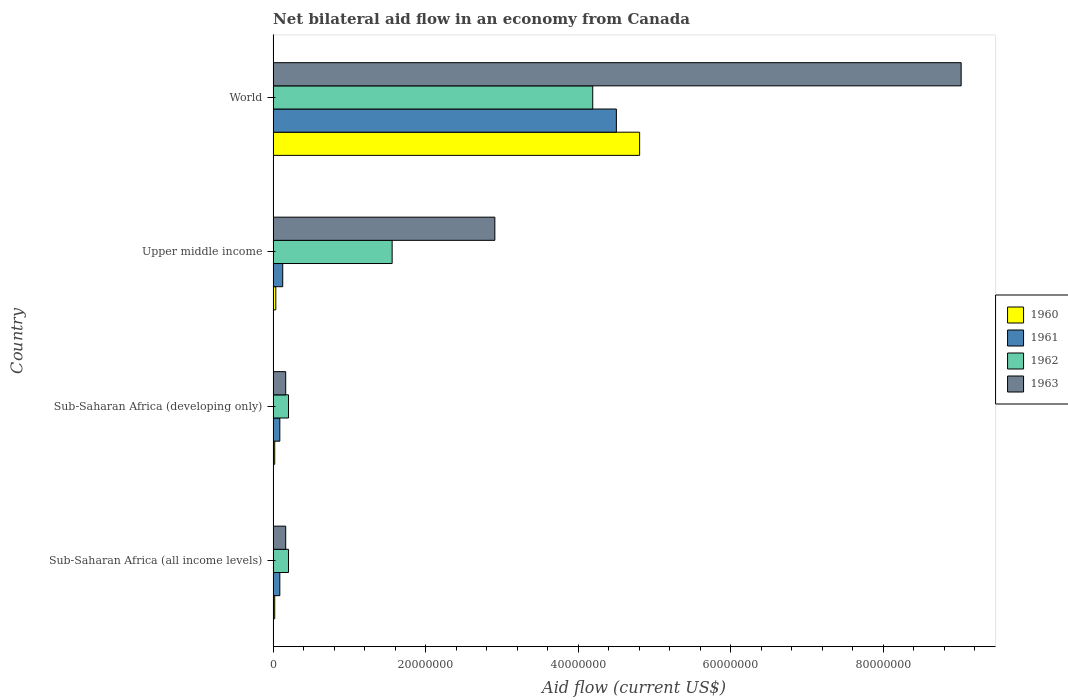How many different coloured bars are there?
Your response must be concise. 4. Are the number of bars per tick equal to the number of legend labels?
Keep it short and to the point. Yes. Are the number of bars on each tick of the Y-axis equal?
Give a very brief answer. Yes. What is the label of the 2nd group of bars from the top?
Your response must be concise. Upper middle income. What is the net bilateral aid flow in 1960 in Sub-Saharan Africa (all income levels)?
Ensure brevity in your answer.  2.10e+05. Across all countries, what is the maximum net bilateral aid flow in 1962?
Give a very brief answer. 4.19e+07. In which country was the net bilateral aid flow in 1963 minimum?
Keep it short and to the point. Sub-Saharan Africa (all income levels). What is the total net bilateral aid flow in 1961 in the graph?
Offer a terse response. 4.80e+07. What is the difference between the net bilateral aid flow in 1960 in World and the net bilateral aid flow in 1963 in Upper middle income?
Provide a succinct answer. 1.90e+07. What is the average net bilateral aid flow in 1961 per country?
Your answer should be compact. 1.20e+07. What is the difference between the net bilateral aid flow in 1962 and net bilateral aid flow in 1961 in World?
Offer a very short reply. -3.10e+06. In how many countries, is the net bilateral aid flow in 1960 greater than 76000000 US$?
Offer a very short reply. 0. What is the difference between the highest and the second highest net bilateral aid flow in 1960?
Give a very brief answer. 4.77e+07. What is the difference between the highest and the lowest net bilateral aid flow in 1961?
Offer a very short reply. 4.41e+07. Is the sum of the net bilateral aid flow in 1960 in Sub-Saharan Africa (developing only) and Upper middle income greater than the maximum net bilateral aid flow in 1961 across all countries?
Offer a terse response. No. Is it the case that in every country, the sum of the net bilateral aid flow in 1961 and net bilateral aid flow in 1963 is greater than the sum of net bilateral aid flow in 1962 and net bilateral aid flow in 1960?
Provide a short and direct response. No. Does the graph contain any zero values?
Offer a terse response. No. Does the graph contain grids?
Your response must be concise. No. What is the title of the graph?
Your answer should be very brief. Net bilateral aid flow in an economy from Canada. Does "2005" appear as one of the legend labels in the graph?
Provide a short and direct response. No. What is the label or title of the X-axis?
Keep it short and to the point. Aid flow (current US$). What is the label or title of the Y-axis?
Provide a succinct answer. Country. What is the Aid flow (current US$) of 1960 in Sub-Saharan Africa (all income levels)?
Provide a succinct answer. 2.10e+05. What is the Aid flow (current US$) in 1961 in Sub-Saharan Africa (all income levels)?
Keep it short and to the point. 8.80e+05. What is the Aid flow (current US$) of 1962 in Sub-Saharan Africa (all income levels)?
Your response must be concise. 2.02e+06. What is the Aid flow (current US$) in 1963 in Sub-Saharan Africa (all income levels)?
Ensure brevity in your answer.  1.65e+06. What is the Aid flow (current US$) of 1960 in Sub-Saharan Africa (developing only)?
Give a very brief answer. 2.10e+05. What is the Aid flow (current US$) of 1961 in Sub-Saharan Africa (developing only)?
Your answer should be very brief. 8.80e+05. What is the Aid flow (current US$) in 1962 in Sub-Saharan Africa (developing only)?
Offer a terse response. 2.02e+06. What is the Aid flow (current US$) of 1963 in Sub-Saharan Africa (developing only)?
Ensure brevity in your answer.  1.65e+06. What is the Aid flow (current US$) of 1960 in Upper middle income?
Your answer should be very brief. 3.50e+05. What is the Aid flow (current US$) in 1961 in Upper middle income?
Give a very brief answer. 1.26e+06. What is the Aid flow (current US$) in 1962 in Upper middle income?
Your answer should be very brief. 1.56e+07. What is the Aid flow (current US$) in 1963 in Upper middle income?
Ensure brevity in your answer.  2.91e+07. What is the Aid flow (current US$) in 1960 in World?
Offer a very short reply. 4.81e+07. What is the Aid flow (current US$) in 1961 in World?
Your answer should be very brief. 4.50e+07. What is the Aid flow (current US$) of 1962 in World?
Your answer should be compact. 4.19e+07. What is the Aid flow (current US$) in 1963 in World?
Offer a very short reply. 9.02e+07. Across all countries, what is the maximum Aid flow (current US$) of 1960?
Your answer should be compact. 4.81e+07. Across all countries, what is the maximum Aid flow (current US$) of 1961?
Offer a very short reply. 4.50e+07. Across all countries, what is the maximum Aid flow (current US$) of 1962?
Offer a terse response. 4.19e+07. Across all countries, what is the maximum Aid flow (current US$) in 1963?
Keep it short and to the point. 9.02e+07. Across all countries, what is the minimum Aid flow (current US$) in 1960?
Keep it short and to the point. 2.10e+05. Across all countries, what is the minimum Aid flow (current US$) of 1961?
Your answer should be very brief. 8.80e+05. Across all countries, what is the minimum Aid flow (current US$) in 1962?
Offer a terse response. 2.02e+06. Across all countries, what is the minimum Aid flow (current US$) of 1963?
Make the answer very short. 1.65e+06. What is the total Aid flow (current US$) in 1960 in the graph?
Offer a very short reply. 4.88e+07. What is the total Aid flow (current US$) of 1961 in the graph?
Provide a succinct answer. 4.80e+07. What is the total Aid flow (current US$) of 1962 in the graph?
Offer a very short reply. 6.16e+07. What is the total Aid flow (current US$) of 1963 in the graph?
Keep it short and to the point. 1.23e+08. What is the difference between the Aid flow (current US$) in 1960 in Sub-Saharan Africa (all income levels) and that in Sub-Saharan Africa (developing only)?
Provide a short and direct response. 0. What is the difference between the Aid flow (current US$) of 1962 in Sub-Saharan Africa (all income levels) and that in Sub-Saharan Africa (developing only)?
Your answer should be compact. 0. What is the difference between the Aid flow (current US$) of 1961 in Sub-Saharan Africa (all income levels) and that in Upper middle income?
Provide a short and direct response. -3.80e+05. What is the difference between the Aid flow (current US$) of 1962 in Sub-Saharan Africa (all income levels) and that in Upper middle income?
Make the answer very short. -1.36e+07. What is the difference between the Aid flow (current US$) of 1963 in Sub-Saharan Africa (all income levels) and that in Upper middle income?
Give a very brief answer. -2.74e+07. What is the difference between the Aid flow (current US$) of 1960 in Sub-Saharan Africa (all income levels) and that in World?
Make the answer very short. -4.79e+07. What is the difference between the Aid flow (current US$) of 1961 in Sub-Saharan Africa (all income levels) and that in World?
Provide a succinct answer. -4.41e+07. What is the difference between the Aid flow (current US$) in 1962 in Sub-Saharan Africa (all income levels) and that in World?
Offer a terse response. -3.99e+07. What is the difference between the Aid flow (current US$) in 1963 in Sub-Saharan Africa (all income levels) and that in World?
Offer a very short reply. -8.86e+07. What is the difference between the Aid flow (current US$) in 1961 in Sub-Saharan Africa (developing only) and that in Upper middle income?
Offer a terse response. -3.80e+05. What is the difference between the Aid flow (current US$) of 1962 in Sub-Saharan Africa (developing only) and that in Upper middle income?
Give a very brief answer. -1.36e+07. What is the difference between the Aid flow (current US$) of 1963 in Sub-Saharan Africa (developing only) and that in Upper middle income?
Your response must be concise. -2.74e+07. What is the difference between the Aid flow (current US$) of 1960 in Sub-Saharan Africa (developing only) and that in World?
Offer a very short reply. -4.79e+07. What is the difference between the Aid flow (current US$) of 1961 in Sub-Saharan Africa (developing only) and that in World?
Give a very brief answer. -4.41e+07. What is the difference between the Aid flow (current US$) in 1962 in Sub-Saharan Africa (developing only) and that in World?
Your answer should be compact. -3.99e+07. What is the difference between the Aid flow (current US$) in 1963 in Sub-Saharan Africa (developing only) and that in World?
Your answer should be very brief. -8.86e+07. What is the difference between the Aid flow (current US$) of 1960 in Upper middle income and that in World?
Give a very brief answer. -4.77e+07. What is the difference between the Aid flow (current US$) in 1961 in Upper middle income and that in World?
Your response must be concise. -4.38e+07. What is the difference between the Aid flow (current US$) of 1962 in Upper middle income and that in World?
Your answer should be compact. -2.63e+07. What is the difference between the Aid flow (current US$) of 1963 in Upper middle income and that in World?
Make the answer very short. -6.12e+07. What is the difference between the Aid flow (current US$) in 1960 in Sub-Saharan Africa (all income levels) and the Aid flow (current US$) in 1961 in Sub-Saharan Africa (developing only)?
Offer a very short reply. -6.70e+05. What is the difference between the Aid flow (current US$) of 1960 in Sub-Saharan Africa (all income levels) and the Aid flow (current US$) of 1962 in Sub-Saharan Africa (developing only)?
Give a very brief answer. -1.81e+06. What is the difference between the Aid flow (current US$) of 1960 in Sub-Saharan Africa (all income levels) and the Aid flow (current US$) of 1963 in Sub-Saharan Africa (developing only)?
Give a very brief answer. -1.44e+06. What is the difference between the Aid flow (current US$) in 1961 in Sub-Saharan Africa (all income levels) and the Aid flow (current US$) in 1962 in Sub-Saharan Africa (developing only)?
Provide a succinct answer. -1.14e+06. What is the difference between the Aid flow (current US$) in 1961 in Sub-Saharan Africa (all income levels) and the Aid flow (current US$) in 1963 in Sub-Saharan Africa (developing only)?
Your response must be concise. -7.70e+05. What is the difference between the Aid flow (current US$) of 1962 in Sub-Saharan Africa (all income levels) and the Aid flow (current US$) of 1963 in Sub-Saharan Africa (developing only)?
Your response must be concise. 3.70e+05. What is the difference between the Aid flow (current US$) in 1960 in Sub-Saharan Africa (all income levels) and the Aid flow (current US$) in 1961 in Upper middle income?
Give a very brief answer. -1.05e+06. What is the difference between the Aid flow (current US$) of 1960 in Sub-Saharan Africa (all income levels) and the Aid flow (current US$) of 1962 in Upper middle income?
Your answer should be very brief. -1.54e+07. What is the difference between the Aid flow (current US$) of 1960 in Sub-Saharan Africa (all income levels) and the Aid flow (current US$) of 1963 in Upper middle income?
Your answer should be very brief. -2.89e+07. What is the difference between the Aid flow (current US$) in 1961 in Sub-Saharan Africa (all income levels) and the Aid flow (current US$) in 1962 in Upper middle income?
Provide a succinct answer. -1.47e+07. What is the difference between the Aid flow (current US$) of 1961 in Sub-Saharan Africa (all income levels) and the Aid flow (current US$) of 1963 in Upper middle income?
Offer a very short reply. -2.82e+07. What is the difference between the Aid flow (current US$) of 1962 in Sub-Saharan Africa (all income levels) and the Aid flow (current US$) of 1963 in Upper middle income?
Keep it short and to the point. -2.71e+07. What is the difference between the Aid flow (current US$) of 1960 in Sub-Saharan Africa (all income levels) and the Aid flow (current US$) of 1961 in World?
Offer a terse response. -4.48e+07. What is the difference between the Aid flow (current US$) in 1960 in Sub-Saharan Africa (all income levels) and the Aid flow (current US$) in 1962 in World?
Provide a short and direct response. -4.17e+07. What is the difference between the Aid flow (current US$) in 1960 in Sub-Saharan Africa (all income levels) and the Aid flow (current US$) in 1963 in World?
Provide a succinct answer. -9.00e+07. What is the difference between the Aid flow (current US$) of 1961 in Sub-Saharan Africa (all income levels) and the Aid flow (current US$) of 1962 in World?
Your answer should be very brief. -4.10e+07. What is the difference between the Aid flow (current US$) in 1961 in Sub-Saharan Africa (all income levels) and the Aid flow (current US$) in 1963 in World?
Your answer should be very brief. -8.94e+07. What is the difference between the Aid flow (current US$) of 1962 in Sub-Saharan Africa (all income levels) and the Aid flow (current US$) of 1963 in World?
Give a very brief answer. -8.82e+07. What is the difference between the Aid flow (current US$) in 1960 in Sub-Saharan Africa (developing only) and the Aid flow (current US$) in 1961 in Upper middle income?
Your response must be concise. -1.05e+06. What is the difference between the Aid flow (current US$) in 1960 in Sub-Saharan Africa (developing only) and the Aid flow (current US$) in 1962 in Upper middle income?
Your answer should be very brief. -1.54e+07. What is the difference between the Aid flow (current US$) of 1960 in Sub-Saharan Africa (developing only) and the Aid flow (current US$) of 1963 in Upper middle income?
Provide a succinct answer. -2.89e+07. What is the difference between the Aid flow (current US$) in 1961 in Sub-Saharan Africa (developing only) and the Aid flow (current US$) in 1962 in Upper middle income?
Offer a very short reply. -1.47e+07. What is the difference between the Aid flow (current US$) of 1961 in Sub-Saharan Africa (developing only) and the Aid flow (current US$) of 1963 in Upper middle income?
Keep it short and to the point. -2.82e+07. What is the difference between the Aid flow (current US$) of 1962 in Sub-Saharan Africa (developing only) and the Aid flow (current US$) of 1963 in Upper middle income?
Your answer should be compact. -2.71e+07. What is the difference between the Aid flow (current US$) of 1960 in Sub-Saharan Africa (developing only) and the Aid flow (current US$) of 1961 in World?
Give a very brief answer. -4.48e+07. What is the difference between the Aid flow (current US$) of 1960 in Sub-Saharan Africa (developing only) and the Aid flow (current US$) of 1962 in World?
Your answer should be compact. -4.17e+07. What is the difference between the Aid flow (current US$) in 1960 in Sub-Saharan Africa (developing only) and the Aid flow (current US$) in 1963 in World?
Make the answer very short. -9.00e+07. What is the difference between the Aid flow (current US$) in 1961 in Sub-Saharan Africa (developing only) and the Aid flow (current US$) in 1962 in World?
Make the answer very short. -4.10e+07. What is the difference between the Aid flow (current US$) in 1961 in Sub-Saharan Africa (developing only) and the Aid flow (current US$) in 1963 in World?
Your answer should be very brief. -8.94e+07. What is the difference between the Aid flow (current US$) of 1962 in Sub-Saharan Africa (developing only) and the Aid flow (current US$) of 1963 in World?
Ensure brevity in your answer.  -8.82e+07. What is the difference between the Aid flow (current US$) in 1960 in Upper middle income and the Aid flow (current US$) in 1961 in World?
Offer a very short reply. -4.47e+07. What is the difference between the Aid flow (current US$) of 1960 in Upper middle income and the Aid flow (current US$) of 1962 in World?
Your answer should be compact. -4.16e+07. What is the difference between the Aid flow (current US$) in 1960 in Upper middle income and the Aid flow (current US$) in 1963 in World?
Your answer should be very brief. -8.99e+07. What is the difference between the Aid flow (current US$) of 1961 in Upper middle income and the Aid flow (current US$) of 1962 in World?
Make the answer very short. -4.07e+07. What is the difference between the Aid flow (current US$) in 1961 in Upper middle income and the Aid flow (current US$) in 1963 in World?
Provide a short and direct response. -8.90e+07. What is the difference between the Aid flow (current US$) in 1962 in Upper middle income and the Aid flow (current US$) in 1963 in World?
Offer a terse response. -7.46e+07. What is the average Aid flow (current US$) of 1960 per country?
Make the answer very short. 1.22e+07. What is the average Aid flow (current US$) in 1961 per country?
Keep it short and to the point. 1.20e+07. What is the average Aid flow (current US$) in 1962 per country?
Provide a short and direct response. 1.54e+07. What is the average Aid flow (current US$) in 1963 per country?
Ensure brevity in your answer.  3.07e+07. What is the difference between the Aid flow (current US$) of 1960 and Aid flow (current US$) of 1961 in Sub-Saharan Africa (all income levels)?
Ensure brevity in your answer.  -6.70e+05. What is the difference between the Aid flow (current US$) in 1960 and Aid flow (current US$) in 1962 in Sub-Saharan Africa (all income levels)?
Make the answer very short. -1.81e+06. What is the difference between the Aid flow (current US$) of 1960 and Aid flow (current US$) of 1963 in Sub-Saharan Africa (all income levels)?
Ensure brevity in your answer.  -1.44e+06. What is the difference between the Aid flow (current US$) in 1961 and Aid flow (current US$) in 1962 in Sub-Saharan Africa (all income levels)?
Your answer should be compact. -1.14e+06. What is the difference between the Aid flow (current US$) in 1961 and Aid flow (current US$) in 1963 in Sub-Saharan Africa (all income levels)?
Offer a terse response. -7.70e+05. What is the difference between the Aid flow (current US$) of 1960 and Aid flow (current US$) of 1961 in Sub-Saharan Africa (developing only)?
Keep it short and to the point. -6.70e+05. What is the difference between the Aid flow (current US$) of 1960 and Aid flow (current US$) of 1962 in Sub-Saharan Africa (developing only)?
Provide a short and direct response. -1.81e+06. What is the difference between the Aid flow (current US$) of 1960 and Aid flow (current US$) of 1963 in Sub-Saharan Africa (developing only)?
Your answer should be very brief. -1.44e+06. What is the difference between the Aid flow (current US$) in 1961 and Aid flow (current US$) in 1962 in Sub-Saharan Africa (developing only)?
Your answer should be compact. -1.14e+06. What is the difference between the Aid flow (current US$) of 1961 and Aid flow (current US$) of 1963 in Sub-Saharan Africa (developing only)?
Give a very brief answer. -7.70e+05. What is the difference between the Aid flow (current US$) in 1962 and Aid flow (current US$) in 1963 in Sub-Saharan Africa (developing only)?
Provide a succinct answer. 3.70e+05. What is the difference between the Aid flow (current US$) of 1960 and Aid flow (current US$) of 1961 in Upper middle income?
Make the answer very short. -9.10e+05. What is the difference between the Aid flow (current US$) in 1960 and Aid flow (current US$) in 1962 in Upper middle income?
Your answer should be compact. -1.53e+07. What is the difference between the Aid flow (current US$) in 1960 and Aid flow (current US$) in 1963 in Upper middle income?
Ensure brevity in your answer.  -2.87e+07. What is the difference between the Aid flow (current US$) of 1961 and Aid flow (current US$) of 1962 in Upper middle income?
Offer a terse response. -1.44e+07. What is the difference between the Aid flow (current US$) of 1961 and Aid flow (current US$) of 1963 in Upper middle income?
Offer a terse response. -2.78e+07. What is the difference between the Aid flow (current US$) of 1962 and Aid flow (current US$) of 1963 in Upper middle income?
Your answer should be compact. -1.35e+07. What is the difference between the Aid flow (current US$) of 1960 and Aid flow (current US$) of 1961 in World?
Your answer should be very brief. 3.05e+06. What is the difference between the Aid flow (current US$) in 1960 and Aid flow (current US$) in 1962 in World?
Make the answer very short. 6.15e+06. What is the difference between the Aid flow (current US$) in 1960 and Aid flow (current US$) in 1963 in World?
Your answer should be compact. -4.22e+07. What is the difference between the Aid flow (current US$) in 1961 and Aid flow (current US$) in 1962 in World?
Give a very brief answer. 3.10e+06. What is the difference between the Aid flow (current US$) of 1961 and Aid flow (current US$) of 1963 in World?
Offer a very short reply. -4.52e+07. What is the difference between the Aid flow (current US$) in 1962 and Aid flow (current US$) in 1963 in World?
Give a very brief answer. -4.83e+07. What is the ratio of the Aid flow (current US$) of 1961 in Sub-Saharan Africa (all income levels) to that in Sub-Saharan Africa (developing only)?
Provide a short and direct response. 1. What is the ratio of the Aid flow (current US$) of 1963 in Sub-Saharan Africa (all income levels) to that in Sub-Saharan Africa (developing only)?
Provide a short and direct response. 1. What is the ratio of the Aid flow (current US$) of 1961 in Sub-Saharan Africa (all income levels) to that in Upper middle income?
Make the answer very short. 0.7. What is the ratio of the Aid flow (current US$) in 1962 in Sub-Saharan Africa (all income levels) to that in Upper middle income?
Your response must be concise. 0.13. What is the ratio of the Aid flow (current US$) in 1963 in Sub-Saharan Africa (all income levels) to that in Upper middle income?
Offer a very short reply. 0.06. What is the ratio of the Aid flow (current US$) in 1960 in Sub-Saharan Africa (all income levels) to that in World?
Provide a short and direct response. 0. What is the ratio of the Aid flow (current US$) of 1961 in Sub-Saharan Africa (all income levels) to that in World?
Your answer should be very brief. 0.02. What is the ratio of the Aid flow (current US$) in 1962 in Sub-Saharan Africa (all income levels) to that in World?
Provide a short and direct response. 0.05. What is the ratio of the Aid flow (current US$) in 1963 in Sub-Saharan Africa (all income levels) to that in World?
Provide a short and direct response. 0.02. What is the ratio of the Aid flow (current US$) in 1960 in Sub-Saharan Africa (developing only) to that in Upper middle income?
Provide a succinct answer. 0.6. What is the ratio of the Aid flow (current US$) of 1961 in Sub-Saharan Africa (developing only) to that in Upper middle income?
Your response must be concise. 0.7. What is the ratio of the Aid flow (current US$) in 1962 in Sub-Saharan Africa (developing only) to that in Upper middle income?
Your answer should be compact. 0.13. What is the ratio of the Aid flow (current US$) in 1963 in Sub-Saharan Africa (developing only) to that in Upper middle income?
Make the answer very short. 0.06. What is the ratio of the Aid flow (current US$) in 1960 in Sub-Saharan Africa (developing only) to that in World?
Your answer should be very brief. 0. What is the ratio of the Aid flow (current US$) in 1961 in Sub-Saharan Africa (developing only) to that in World?
Your answer should be very brief. 0.02. What is the ratio of the Aid flow (current US$) in 1962 in Sub-Saharan Africa (developing only) to that in World?
Your answer should be very brief. 0.05. What is the ratio of the Aid flow (current US$) of 1963 in Sub-Saharan Africa (developing only) to that in World?
Your answer should be compact. 0.02. What is the ratio of the Aid flow (current US$) in 1960 in Upper middle income to that in World?
Ensure brevity in your answer.  0.01. What is the ratio of the Aid flow (current US$) in 1961 in Upper middle income to that in World?
Provide a short and direct response. 0.03. What is the ratio of the Aid flow (current US$) in 1962 in Upper middle income to that in World?
Your answer should be very brief. 0.37. What is the ratio of the Aid flow (current US$) in 1963 in Upper middle income to that in World?
Offer a terse response. 0.32. What is the difference between the highest and the second highest Aid flow (current US$) in 1960?
Provide a succinct answer. 4.77e+07. What is the difference between the highest and the second highest Aid flow (current US$) of 1961?
Your answer should be compact. 4.38e+07. What is the difference between the highest and the second highest Aid flow (current US$) in 1962?
Provide a short and direct response. 2.63e+07. What is the difference between the highest and the second highest Aid flow (current US$) in 1963?
Your answer should be compact. 6.12e+07. What is the difference between the highest and the lowest Aid flow (current US$) of 1960?
Make the answer very short. 4.79e+07. What is the difference between the highest and the lowest Aid flow (current US$) in 1961?
Your answer should be very brief. 4.41e+07. What is the difference between the highest and the lowest Aid flow (current US$) in 1962?
Provide a short and direct response. 3.99e+07. What is the difference between the highest and the lowest Aid flow (current US$) in 1963?
Give a very brief answer. 8.86e+07. 